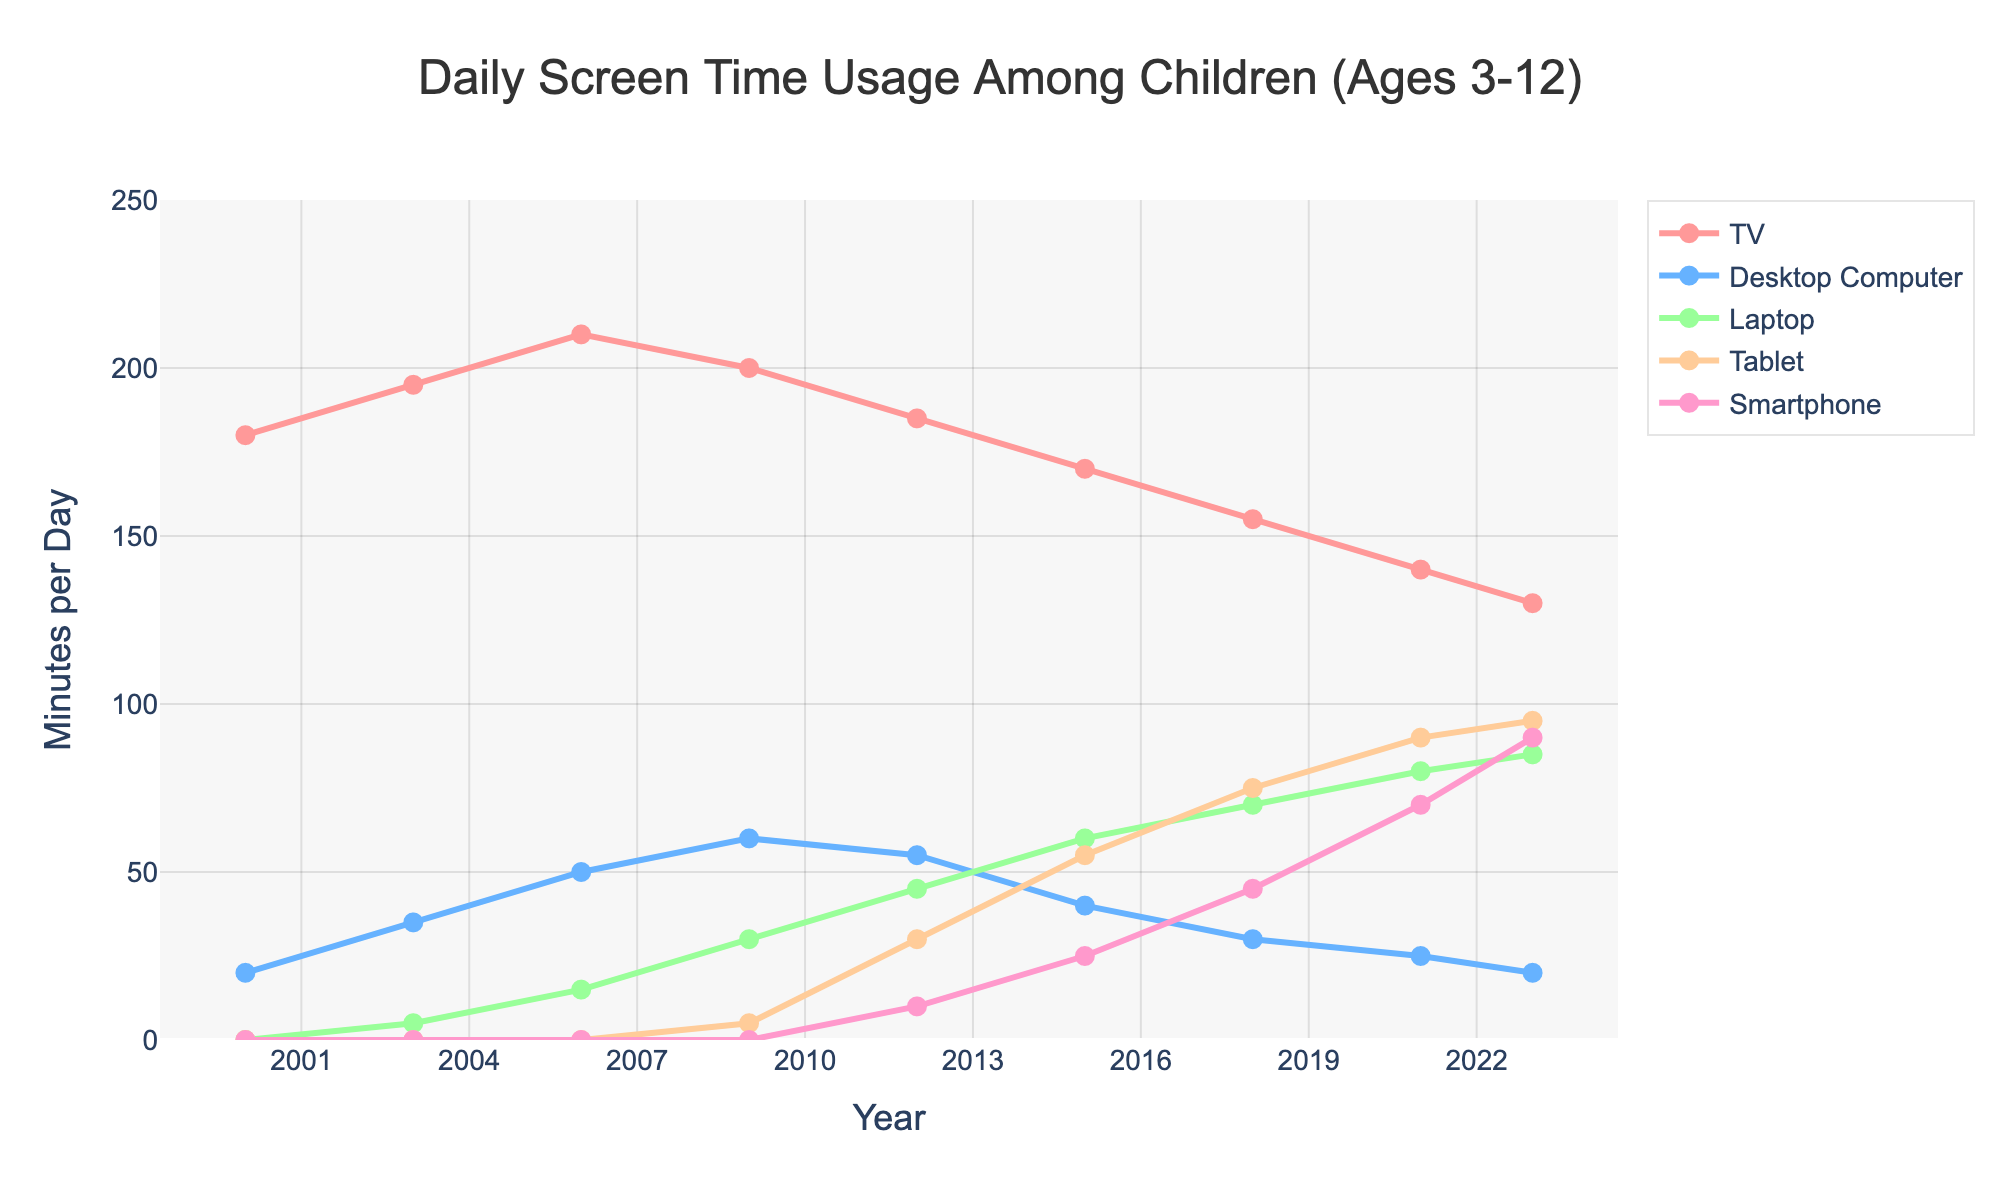What was the average daily screen time for watching TV in the years 2000 and 2023? To find the average daily screen time for watching TV in the years 2000 and 2023, add the screen time from both years and then divide by 2. The screen times are 180 minutes in 2000 and 130 minutes in 2023. (180 + 130) / 2 = 155
Answer: 155 Which device saw the greatest increase in usage from 2000 to 2023? To determine which device saw the greatest increase, calculate the difference in screen time for each device between 2000 and 2023. The increases are as follows: TV: -50, Desktop Computer: 0, Laptop: 85, Tablet: 95, Smartphone: 90. The greatest increase is for Tablets.
Answer: Tablet How did screen time for Desktop Computers in 2023 compare to that in 2003? By observing the screen time values in the years 2023 and 2003 for Desktop Computers, we see that the values are 20 minutes and 35 minutes respectively. So, screen time usage decreased by 15 minutes.
Answer: Decreased by 15 minutes What was the total daily screen time for all devices combined in 2021? Sum the screen time for all devices in the year 2021 which are: TV: 140, Desktop Computer: 25, Laptop: 80, Tablet: 90, Smartphone: 70. Total = 140 + 25 + 80 + 90 + 70 = 405
Answer: 405 Between which consecutive years did the use of Tablets see the largest increase? To find the largest increase, calculate the difference in Tablet usage between consecutive years: (2009-2012: 30-5=25), (2012-2015: 55-30=25), (2015-2018: 75-55=20), (2018-2021: 90-75=15), (2021-2023: 95-90=5). The largest increase was between 2009 and 2012 or between 2012 and 2015, both of which are 25 minutes.
Answer: 2009 to 2012 or 2012 to 2015 In what year did Laptops surpass Desktop Computers in terms of daily screen time usage? By examining the intersection points of the lines representing Laptops and Desktop Computers, Laptops first surpass Desktop Computers around the year 2012.
Answer: 2012 Which device had the highest usage in the year 2018? By looking at the screen time for each device in 2018, the values are: TV: 155, Desktop Computer: 30, Laptop: 70, Tablet: 75, Smartphone: 45. The highest value is for TV.
Answer: TV What is the difference in daily screen time between TV and Smartphones in 2023? In 2023, the screen times for TV and Smartphones are 130 minutes and 90 minutes respectively. The difference is 130 - 90 = 40 minutes.
Answer: 40 By how much did the total daily screen time for all devices combined change from 2015 to 2018? First, calculate the total screen time for all devices in 2015 and 2018. For 2015: TV: 170, Desktop Computer: 40, Laptop: 60, Tablet: 55, Smartphone: 25. Total = 170 + 40 + 60 + 55 + 25 = 350. For 2018: TV: 155, Desktop Computer: 30, Laptop: 70, Tablet: 75, Smartphone: 45. Total = 155 + 30 + 70 + 75 + 45 = 375. Change = 375 - 350 = 25
Answer: 25 